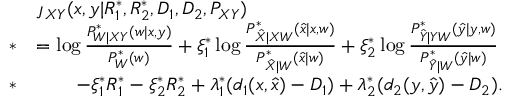<formula> <loc_0><loc_0><loc_500><loc_500>\begin{array} { r l } & { \jmath _ { X Y } ( x , y | R _ { 1 } ^ { * } , R _ { 2 } ^ { * } , D _ { 1 } , D _ { 2 } , P _ { X Y } ) } \\ { * } & { = \log \frac { P _ { W | X Y } ^ { * } ( w | x , y ) } { P _ { W } ^ { * } ( w ) } + \xi _ { 1 } ^ { * } \log \frac { P _ { \hat { X } | X W } ^ { * } ( \hat { x } | x , w ) } { P _ { \hat { X } | W } ^ { * } ( \hat { x } | w ) } + \xi _ { 2 } ^ { * } \log \frac { P _ { \hat { Y } | Y W } ^ { * } ( \hat { y } | y , w ) } { P _ { \hat { Y } | W } ^ { * } ( \hat { y } | w ) } } \\ { * } & { \quad - \xi _ { 1 } ^ { * } R _ { 1 } ^ { * } - \xi _ { 2 } ^ { * } R _ { 2 } ^ { * } + \lambda _ { 1 } ^ { * } ( d _ { 1 } ( x , \hat { x } ) - D _ { 1 } ) + \lambda _ { 2 } ^ { * } ( d _ { 2 } ( y , \hat { y } ) - D _ { 2 } ) . } \end{array}</formula> 